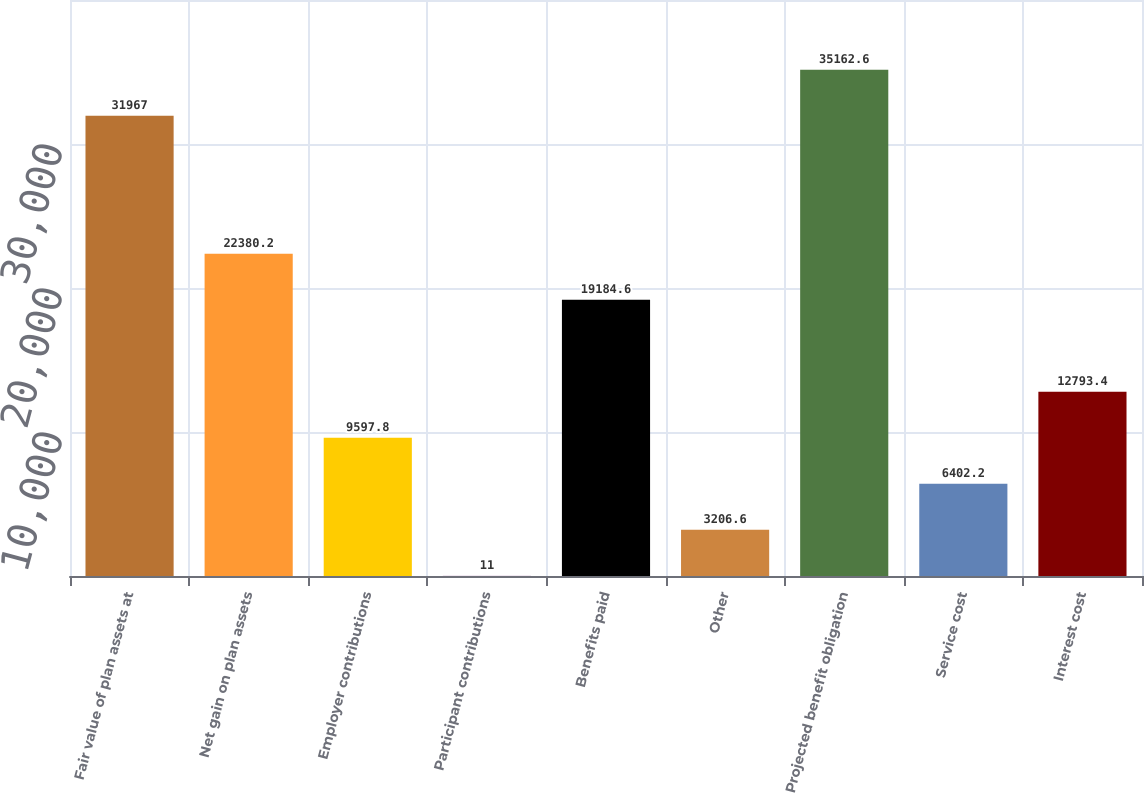Convert chart. <chart><loc_0><loc_0><loc_500><loc_500><bar_chart><fcel>Fair value of plan assets at<fcel>Net gain on plan assets<fcel>Employer contributions<fcel>Participant contributions<fcel>Benefits paid<fcel>Other<fcel>Projected benefit obligation<fcel>Service cost<fcel>Interest cost<nl><fcel>31967<fcel>22380.2<fcel>9597.8<fcel>11<fcel>19184.6<fcel>3206.6<fcel>35162.6<fcel>6402.2<fcel>12793.4<nl></chart> 